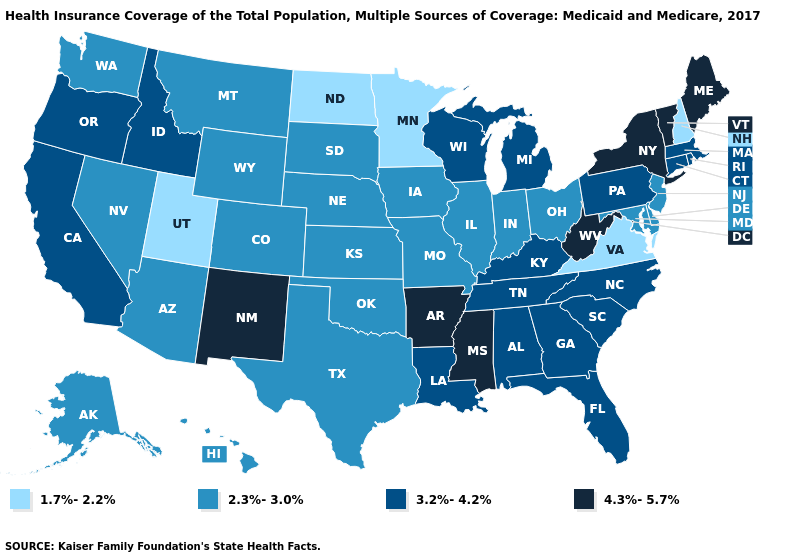Among the states that border Vermont , which have the lowest value?
Be succinct. New Hampshire. Among the states that border South Dakota , does Wyoming have the highest value?
Write a very short answer. Yes. What is the value of Minnesota?
Answer briefly. 1.7%-2.2%. Name the states that have a value in the range 4.3%-5.7%?
Keep it brief. Arkansas, Maine, Mississippi, New Mexico, New York, Vermont, West Virginia. Does South Dakota have the highest value in the MidWest?
Give a very brief answer. No. Name the states that have a value in the range 1.7%-2.2%?
Be succinct. Minnesota, New Hampshire, North Dakota, Utah, Virginia. What is the value of Washington?
Be succinct. 2.3%-3.0%. Name the states that have a value in the range 4.3%-5.7%?
Write a very short answer. Arkansas, Maine, Mississippi, New Mexico, New York, Vermont, West Virginia. Does Texas have the lowest value in the USA?
Be succinct. No. Does Oklahoma have the lowest value in the South?
Write a very short answer. No. Name the states that have a value in the range 3.2%-4.2%?
Answer briefly. Alabama, California, Connecticut, Florida, Georgia, Idaho, Kentucky, Louisiana, Massachusetts, Michigan, North Carolina, Oregon, Pennsylvania, Rhode Island, South Carolina, Tennessee, Wisconsin. Among the states that border Pennsylvania , does New York have the highest value?
Be succinct. Yes. Which states have the highest value in the USA?
Short answer required. Arkansas, Maine, Mississippi, New Mexico, New York, Vermont, West Virginia. Name the states that have a value in the range 2.3%-3.0%?
Answer briefly. Alaska, Arizona, Colorado, Delaware, Hawaii, Illinois, Indiana, Iowa, Kansas, Maryland, Missouri, Montana, Nebraska, Nevada, New Jersey, Ohio, Oklahoma, South Dakota, Texas, Washington, Wyoming. What is the lowest value in states that border South Dakota?
Short answer required. 1.7%-2.2%. 